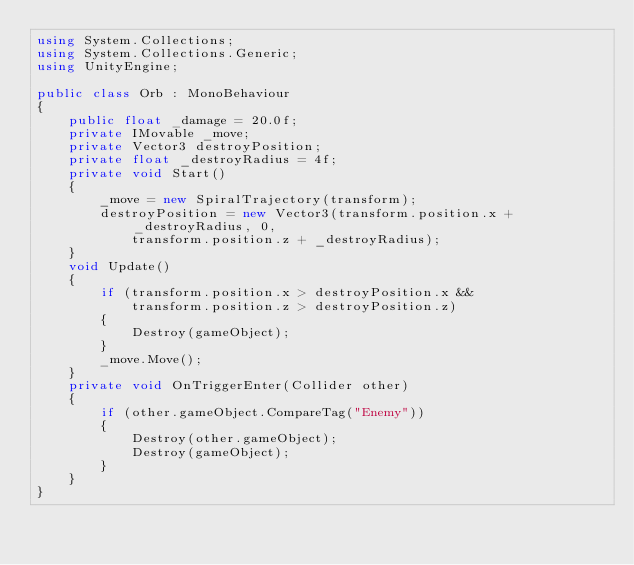<code> <loc_0><loc_0><loc_500><loc_500><_C#_>using System.Collections;
using System.Collections.Generic;
using UnityEngine;

public class Orb : MonoBehaviour
{
    public float _damage = 20.0f;
    private IMovable _move;
    private Vector3 destroyPosition;
    private float _destroyRadius = 4f;
    private void Start()
    {
        _move = new SpiralTrajectory(transform);
        destroyPosition = new Vector3(transform.position.x + _destroyRadius, 0,
            transform.position.z + _destroyRadius);
    }
    void Update()
    {
        if (transform.position.x > destroyPosition.x &&
            transform.position.z > destroyPosition.z)
        {
            Destroy(gameObject);
        }
        _move.Move();
    }
    private void OnTriggerEnter(Collider other)
    {
        if (other.gameObject.CompareTag("Enemy"))
        {
            Destroy(other.gameObject);
            Destroy(gameObject);
        }
    }
}
</code> 